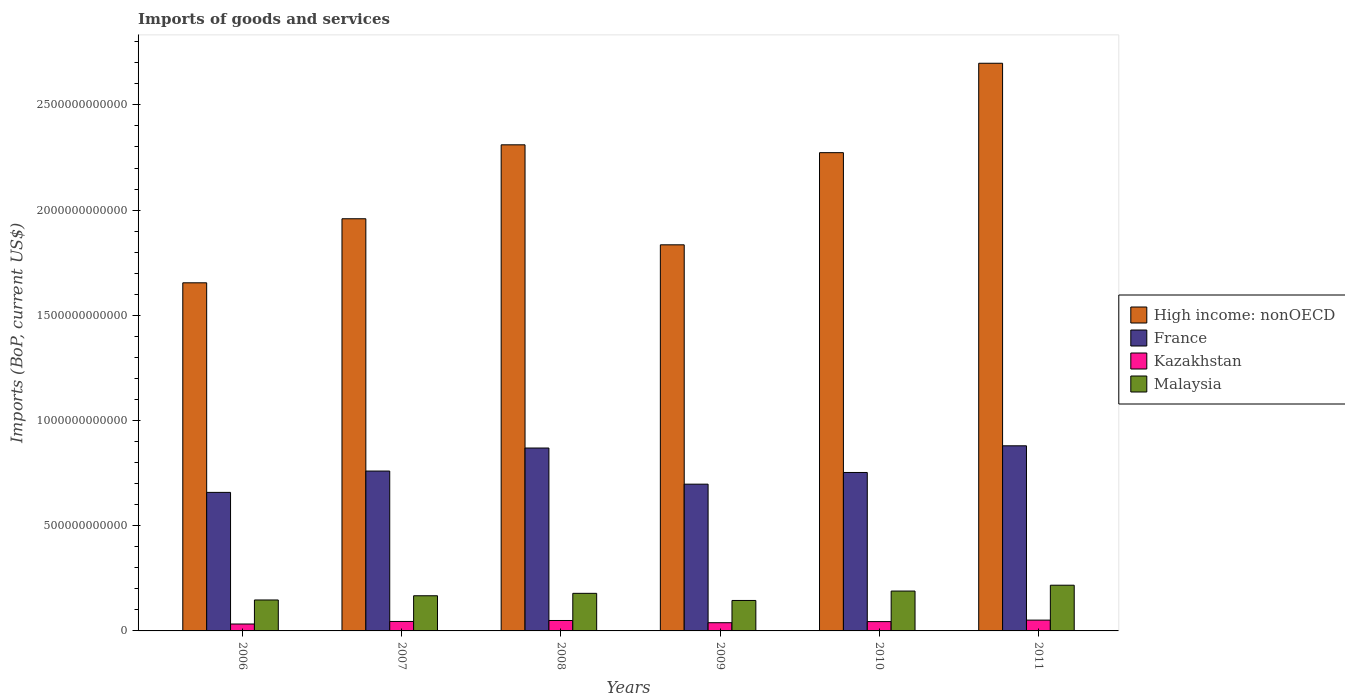Are the number of bars on each tick of the X-axis equal?
Offer a terse response. Yes. How many bars are there on the 4th tick from the left?
Your answer should be very brief. 4. What is the amount spent on imports in France in 2011?
Make the answer very short. 8.80e+11. Across all years, what is the maximum amount spent on imports in France?
Give a very brief answer. 8.80e+11. Across all years, what is the minimum amount spent on imports in Kazakhstan?
Make the answer very short. 3.29e+1. In which year was the amount spent on imports in Kazakhstan minimum?
Your response must be concise. 2006. What is the total amount spent on imports in High income: nonOECD in the graph?
Your answer should be very brief. 1.27e+13. What is the difference between the amount spent on imports in High income: nonOECD in 2007 and that in 2009?
Provide a short and direct response. 1.24e+11. What is the difference between the amount spent on imports in Kazakhstan in 2008 and the amount spent on imports in Malaysia in 2011?
Make the answer very short. -1.68e+11. What is the average amount spent on imports in France per year?
Offer a very short reply. 7.70e+11. In the year 2010, what is the difference between the amount spent on imports in High income: nonOECD and amount spent on imports in Kazakhstan?
Offer a terse response. 2.23e+12. What is the ratio of the amount spent on imports in High income: nonOECD in 2006 to that in 2007?
Your answer should be compact. 0.84. Is the difference between the amount spent on imports in High income: nonOECD in 2007 and 2010 greater than the difference between the amount spent on imports in Kazakhstan in 2007 and 2010?
Your response must be concise. No. What is the difference between the highest and the second highest amount spent on imports in Malaysia?
Provide a short and direct response. 2.78e+1. What is the difference between the highest and the lowest amount spent on imports in Kazakhstan?
Keep it short and to the point. 1.84e+1. In how many years, is the amount spent on imports in Kazakhstan greater than the average amount spent on imports in Kazakhstan taken over all years?
Provide a succinct answer. 4. What does the 1st bar from the left in 2009 represents?
Provide a succinct answer. High income: nonOECD. How many years are there in the graph?
Keep it short and to the point. 6. What is the difference between two consecutive major ticks on the Y-axis?
Provide a short and direct response. 5.00e+11. Are the values on the major ticks of Y-axis written in scientific E-notation?
Make the answer very short. No. Does the graph contain any zero values?
Offer a very short reply. No. Does the graph contain grids?
Give a very brief answer. No. Where does the legend appear in the graph?
Ensure brevity in your answer.  Center right. How are the legend labels stacked?
Your response must be concise. Vertical. What is the title of the graph?
Offer a very short reply. Imports of goods and services. What is the label or title of the Y-axis?
Your answer should be compact. Imports (BoP, current US$). What is the Imports (BoP, current US$) in High income: nonOECD in 2006?
Your answer should be compact. 1.65e+12. What is the Imports (BoP, current US$) of France in 2006?
Keep it short and to the point. 6.58e+11. What is the Imports (BoP, current US$) in Kazakhstan in 2006?
Provide a succinct answer. 3.29e+1. What is the Imports (BoP, current US$) in Malaysia in 2006?
Ensure brevity in your answer.  1.47e+11. What is the Imports (BoP, current US$) in High income: nonOECD in 2007?
Keep it short and to the point. 1.96e+12. What is the Imports (BoP, current US$) in France in 2007?
Offer a very short reply. 7.60e+11. What is the Imports (BoP, current US$) of Kazakhstan in 2007?
Give a very brief answer. 4.50e+1. What is the Imports (BoP, current US$) in Malaysia in 2007?
Your answer should be compact. 1.67e+11. What is the Imports (BoP, current US$) in High income: nonOECD in 2008?
Ensure brevity in your answer.  2.31e+12. What is the Imports (BoP, current US$) of France in 2008?
Keep it short and to the point. 8.69e+11. What is the Imports (BoP, current US$) in Kazakhstan in 2008?
Your answer should be compact. 4.96e+1. What is the Imports (BoP, current US$) in Malaysia in 2008?
Your answer should be very brief. 1.79e+11. What is the Imports (BoP, current US$) of High income: nonOECD in 2009?
Provide a short and direct response. 1.83e+12. What is the Imports (BoP, current US$) in France in 2009?
Give a very brief answer. 6.97e+11. What is the Imports (BoP, current US$) of Kazakhstan in 2009?
Provide a succinct answer. 3.90e+1. What is the Imports (BoP, current US$) of Malaysia in 2009?
Make the answer very short. 1.45e+11. What is the Imports (BoP, current US$) in High income: nonOECD in 2010?
Ensure brevity in your answer.  2.27e+12. What is the Imports (BoP, current US$) in France in 2010?
Offer a very short reply. 7.53e+11. What is the Imports (BoP, current US$) in Kazakhstan in 2010?
Give a very brief answer. 4.43e+1. What is the Imports (BoP, current US$) of Malaysia in 2010?
Provide a short and direct response. 1.89e+11. What is the Imports (BoP, current US$) in High income: nonOECD in 2011?
Offer a terse response. 2.70e+12. What is the Imports (BoP, current US$) in France in 2011?
Ensure brevity in your answer.  8.80e+11. What is the Imports (BoP, current US$) in Kazakhstan in 2011?
Offer a terse response. 5.13e+1. What is the Imports (BoP, current US$) in Malaysia in 2011?
Ensure brevity in your answer.  2.17e+11. Across all years, what is the maximum Imports (BoP, current US$) of High income: nonOECD?
Your answer should be very brief. 2.70e+12. Across all years, what is the maximum Imports (BoP, current US$) in France?
Provide a short and direct response. 8.80e+11. Across all years, what is the maximum Imports (BoP, current US$) of Kazakhstan?
Provide a short and direct response. 5.13e+1. Across all years, what is the maximum Imports (BoP, current US$) of Malaysia?
Ensure brevity in your answer.  2.17e+11. Across all years, what is the minimum Imports (BoP, current US$) in High income: nonOECD?
Your answer should be very brief. 1.65e+12. Across all years, what is the minimum Imports (BoP, current US$) in France?
Your answer should be compact. 6.58e+11. Across all years, what is the minimum Imports (BoP, current US$) of Kazakhstan?
Provide a short and direct response. 3.29e+1. Across all years, what is the minimum Imports (BoP, current US$) in Malaysia?
Make the answer very short. 1.45e+11. What is the total Imports (BoP, current US$) of High income: nonOECD in the graph?
Make the answer very short. 1.27e+13. What is the total Imports (BoP, current US$) in France in the graph?
Provide a short and direct response. 4.62e+12. What is the total Imports (BoP, current US$) in Kazakhstan in the graph?
Make the answer very short. 2.62e+11. What is the total Imports (BoP, current US$) of Malaysia in the graph?
Your response must be concise. 1.04e+12. What is the difference between the Imports (BoP, current US$) in High income: nonOECD in 2006 and that in 2007?
Offer a very short reply. -3.04e+11. What is the difference between the Imports (BoP, current US$) of France in 2006 and that in 2007?
Give a very brief answer. -1.01e+11. What is the difference between the Imports (BoP, current US$) of Kazakhstan in 2006 and that in 2007?
Your answer should be very brief. -1.21e+1. What is the difference between the Imports (BoP, current US$) in Malaysia in 2006 and that in 2007?
Make the answer very short. -2.00e+1. What is the difference between the Imports (BoP, current US$) in High income: nonOECD in 2006 and that in 2008?
Provide a succinct answer. -6.56e+11. What is the difference between the Imports (BoP, current US$) in France in 2006 and that in 2008?
Offer a very short reply. -2.11e+11. What is the difference between the Imports (BoP, current US$) in Kazakhstan in 2006 and that in 2008?
Your answer should be compact. -1.67e+1. What is the difference between the Imports (BoP, current US$) of Malaysia in 2006 and that in 2008?
Provide a short and direct response. -3.16e+1. What is the difference between the Imports (BoP, current US$) in High income: nonOECD in 2006 and that in 2009?
Offer a very short reply. -1.81e+11. What is the difference between the Imports (BoP, current US$) of France in 2006 and that in 2009?
Make the answer very short. -3.90e+1. What is the difference between the Imports (BoP, current US$) in Kazakhstan in 2006 and that in 2009?
Offer a very short reply. -6.12e+09. What is the difference between the Imports (BoP, current US$) of Malaysia in 2006 and that in 2009?
Provide a succinct answer. 2.30e+09. What is the difference between the Imports (BoP, current US$) of High income: nonOECD in 2006 and that in 2010?
Your answer should be compact. -6.19e+11. What is the difference between the Imports (BoP, current US$) of France in 2006 and that in 2010?
Your response must be concise. -9.46e+1. What is the difference between the Imports (BoP, current US$) of Kazakhstan in 2006 and that in 2010?
Offer a very short reply. -1.14e+1. What is the difference between the Imports (BoP, current US$) of Malaysia in 2006 and that in 2010?
Ensure brevity in your answer.  -4.24e+1. What is the difference between the Imports (BoP, current US$) of High income: nonOECD in 2006 and that in 2011?
Make the answer very short. -1.04e+12. What is the difference between the Imports (BoP, current US$) in France in 2006 and that in 2011?
Your answer should be compact. -2.21e+11. What is the difference between the Imports (BoP, current US$) in Kazakhstan in 2006 and that in 2011?
Ensure brevity in your answer.  -1.84e+1. What is the difference between the Imports (BoP, current US$) in Malaysia in 2006 and that in 2011?
Provide a succinct answer. -7.02e+1. What is the difference between the Imports (BoP, current US$) in High income: nonOECD in 2007 and that in 2008?
Provide a succinct answer. -3.51e+11. What is the difference between the Imports (BoP, current US$) of France in 2007 and that in 2008?
Ensure brevity in your answer.  -1.09e+11. What is the difference between the Imports (BoP, current US$) of Kazakhstan in 2007 and that in 2008?
Provide a short and direct response. -4.58e+09. What is the difference between the Imports (BoP, current US$) in Malaysia in 2007 and that in 2008?
Offer a terse response. -1.16e+1. What is the difference between the Imports (BoP, current US$) in High income: nonOECD in 2007 and that in 2009?
Ensure brevity in your answer.  1.24e+11. What is the difference between the Imports (BoP, current US$) in France in 2007 and that in 2009?
Offer a very short reply. 6.23e+1. What is the difference between the Imports (BoP, current US$) in Kazakhstan in 2007 and that in 2009?
Provide a short and direct response. 5.99e+09. What is the difference between the Imports (BoP, current US$) of Malaysia in 2007 and that in 2009?
Keep it short and to the point. 2.23e+1. What is the difference between the Imports (BoP, current US$) of High income: nonOECD in 2007 and that in 2010?
Your answer should be compact. -3.14e+11. What is the difference between the Imports (BoP, current US$) of France in 2007 and that in 2010?
Offer a terse response. 6.70e+09. What is the difference between the Imports (BoP, current US$) in Kazakhstan in 2007 and that in 2010?
Make the answer very short. 7.30e+08. What is the difference between the Imports (BoP, current US$) of Malaysia in 2007 and that in 2010?
Your answer should be very brief. -2.24e+1. What is the difference between the Imports (BoP, current US$) of High income: nonOECD in 2007 and that in 2011?
Offer a terse response. -7.39e+11. What is the difference between the Imports (BoP, current US$) in France in 2007 and that in 2011?
Your response must be concise. -1.20e+11. What is the difference between the Imports (BoP, current US$) in Kazakhstan in 2007 and that in 2011?
Provide a short and direct response. -6.33e+09. What is the difference between the Imports (BoP, current US$) of Malaysia in 2007 and that in 2011?
Your answer should be compact. -5.02e+1. What is the difference between the Imports (BoP, current US$) of High income: nonOECD in 2008 and that in 2009?
Ensure brevity in your answer.  4.75e+11. What is the difference between the Imports (BoP, current US$) of France in 2008 and that in 2009?
Provide a succinct answer. 1.72e+11. What is the difference between the Imports (BoP, current US$) in Kazakhstan in 2008 and that in 2009?
Give a very brief answer. 1.06e+1. What is the difference between the Imports (BoP, current US$) in Malaysia in 2008 and that in 2009?
Your response must be concise. 3.39e+1. What is the difference between the Imports (BoP, current US$) in High income: nonOECD in 2008 and that in 2010?
Your answer should be very brief. 3.72e+1. What is the difference between the Imports (BoP, current US$) of France in 2008 and that in 2010?
Ensure brevity in your answer.  1.16e+11. What is the difference between the Imports (BoP, current US$) of Kazakhstan in 2008 and that in 2010?
Your answer should be compact. 5.31e+09. What is the difference between the Imports (BoP, current US$) of Malaysia in 2008 and that in 2010?
Your answer should be compact. -1.08e+1. What is the difference between the Imports (BoP, current US$) in High income: nonOECD in 2008 and that in 2011?
Ensure brevity in your answer.  -3.88e+11. What is the difference between the Imports (BoP, current US$) in France in 2008 and that in 2011?
Give a very brief answer. -1.06e+1. What is the difference between the Imports (BoP, current US$) in Kazakhstan in 2008 and that in 2011?
Make the answer very short. -1.75e+09. What is the difference between the Imports (BoP, current US$) of Malaysia in 2008 and that in 2011?
Your answer should be compact. -3.86e+1. What is the difference between the Imports (BoP, current US$) in High income: nonOECD in 2009 and that in 2010?
Your answer should be very brief. -4.38e+11. What is the difference between the Imports (BoP, current US$) of France in 2009 and that in 2010?
Your response must be concise. -5.56e+1. What is the difference between the Imports (BoP, current US$) in Kazakhstan in 2009 and that in 2010?
Your answer should be compact. -5.26e+09. What is the difference between the Imports (BoP, current US$) of Malaysia in 2009 and that in 2010?
Your answer should be very brief. -4.47e+1. What is the difference between the Imports (BoP, current US$) of High income: nonOECD in 2009 and that in 2011?
Provide a succinct answer. -8.63e+11. What is the difference between the Imports (BoP, current US$) of France in 2009 and that in 2011?
Provide a short and direct response. -1.82e+11. What is the difference between the Imports (BoP, current US$) of Kazakhstan in 2009 and that in 2011?
Offer a very short reply. -1.23e+1. What is the difference between the Imports (BoP, current US$) of Malaysia in 2009 and that in 2011?
Provide a succinct answer. -7.25e+1. What is the difference between the Imports (BoP, current US$) of High income: nonOECD in 2010 and that in 2011?
Provide a succinct answer. -4.25e+11. What is the difference between the Imports (BoP, current US$) of France in 2010 and that in 2011?
Your answer should be compact. -1.27e+11. What is the difference between the Imports (BoP, current US$) of Kazakhstan in 2010 and that in 2011?
Offer a very short reply. -7.06e+09. What is the difference between the Imports (BoP, current US$) of Malaysia in 2010 and that in 2011?
Your response must be concise. -2.78e+1. What is the difference between the Imports (BoP, current US$) in High income: nonOECD in 2006 and the Imports (BoP, current US$) in France in 2007?
Your response must be concise. 8.95e+11. What is the difference between the Imports (BoP, current US$) of High income: nonOECD in 2006 and the Imports (BoP, current US$) of Kazakhstan in 2007?
Ensure brevity in your answer.  1.61e+12. What is the difference between the Imports (BoP, current US$) of High income: nonOECD in 2006 and the Imports (BoP, current US$) of Malaysia in 2007?
Provide a succinct answer. 1.49e+12. What is the difference between the Imports (BoP, current US$) in France in 2006 and the Imports (BoP, current US$) in Kazakhstan in 2007?
Keep it short and to the point. 6.13e+11. What is the difference between the Imports (BoP, current US$) of France in 2006 and the Imports (BoP, current US$) of Malaysia in 2007?
Provide a succinct answer. 4.91e+11. What is the difference between the Imports (BoP, current US$) in Kazakhstan in 2006 and the Imports (BoP, current US$) in Malaysia in 2007?
Give a very brief answer. -1.34e+11. What is the difference between the Imports (BoP, current US$) in High income: nonOECD in 2006 and the Imports (BoP, current US$) in France in 2008?
Make the answer very short. 7.85e+11. What is the difference between the Imports (BoP, current US$) of High income: nonOECD in 2006 and the Imports (BoP, current US$) of Kazakhstan in 2008?
Provide a short and direct response. 1.60e+12. What is the difference between the Imports (BoP, current US$) in High income: nonOECD in 2006 and the Imports (BoP, current US$) in Malaysia in 2008?
Offer a terse response. 1.48e+12. What is the difference between the Imports (BoP, current US$) in France in 2006 and the Imports (BoP, current US$) in Kazakhstan in 2008?
Your answer should be compact. 6.09e+11. What is the difference between the Imports (BoP, current US$) in France in 2006 and the Imports (BoP, current US$) in Malaysia in 2008?
Make the answer very short. 4.80e+11. What is the difference between the Imports (BoP, current US$) of Kazakhstan in 2006 and the Imports (BoP, current US$) of Malaysia in 2008?
Make the answer very short. -1.46e+11. What is the difference between the Imports (BoP, current US$) in High income: nonOECD in 2006 and the Imports (BoP, current US$) in France in 2009?
Your response must be concise. 9.57e+11. What is the difference between the Imports (BoP, current US$) in High income: nonOECD in 2006 and the Imports (BoP, current US$) in Kazakhstan in 2009?
Offer a terse response. 1.62e+12. What is the difference between the Imports (BoP, current US$) in High income: nonOECD in 2006 and the Imports (BoP, current US$) in Malaysia in 2009?
Give a very brief answer. 1.51e+12. What is the difference between the Imports (BoP, current US$) of France in 2006 and the Imports (BoP, current US$) of Kazakhstan in 2009?
Offer a very short reply. 6.19e+11. What is the difference between the Imports (BoP, current US$) of France in 2006 and the Imports (BoP, current US$) of Malaysia in 2009?
Provide a short and direct response. 5.14e+11. What is the difference between the Imports (BoP, current US$) in Kazakhstan in 2006 and the Imports (BoP, current US$) in Malaysia in 2009?
Keep it short and to the point. -1.12e+11. What is the difference between the Imports (BoP, current US$) in High income: nonOECD in 2006 and the Imports (BoP, current US$) in France in 2010?
Provide a succinct answer. 9.01e+11. What is the difference between the Imports (BoP, current US$) of High income: nonOECD in 2006 and the Imports (BoP, current US$) of Kazakhstan in 2010?
Your answer should be compact. 1.61e+12. What is the difference between the Imports (BoP, current US$) of High income: nonOECD in 2006 and the Imports (BoP, current US$) of Malaysia in 2010?
Keep it short and to the point. 1.46e+12. What is the difference between the Imports (BoP, current US$) in France in 2006 and the Imports (BoP, current US$) in Kazakhstan in 2010?
Your answer should be very brief. 6.14e+11. What is the difference between the Imports (BoP, current US$) in France in 2006 and the Imports (BoP, current US$) in Malaysia in 2010?
Offer a terse response. 4.69e+11. What is the difference between the Imports (BoP, current US$) of Kazakhstan in 2006 and the Imports (BoP, current US$) of Malaysia in 2010?
Keep it short and to the point. -1.57e+11. What is the difference between the Imports (BoP, current US$) in High income: nonOECD in 2006 and the Imports (BoP, current US$) in France in 2011?
Ensure brevity in your answer.  7.75e+11. What is the difference between the Imports (BoP, current US$) in High income: nonOECD in 2006 and the Imports (BoP, current US$) in Kazakhstan in 2011?
Ensure brevity in your answer.  1.60e+12. What is the difference between the Imports (BoP, current US$) of High income: nonOECD in 2006 and the Imports (BoP, current US$) of Malaysia in 2011?
Keep it short and to the point. 1.44e+12. What is the difference between the Imports (BoP, current US$) of France in 2006 and the Imports (BoP, current US$) of Kazakhstan in 2011?
Offer a very short reply. 6.07e+11. What is the difference between the Imports (BoP, current US$) of France in 2006 and the Imports (BoP, current US$) of Malaysia in 2011?
Give a very brief answer. 4.41e+11. What is the difference between the Imports (BoP, current US$) in Kazakhstan in 2006 and the Imports (BoP, current US$) in Malaysia in 2011?
Make the answer very short. -1.84e+11. What is the difference between the Imports (BoP, current US$) in High income: nonOECD in 2007 and the Imports (BoP, current US$) in France in 2008?
Give a very brief answer. 1.09e+12. What is the difference between the Imports (BoP, current US$) of High income: nonOECD in 2007 and the Imports (BoP, current US$) of Kazakhstan in 2008?
Provide a succinct answer. 1.91e+12. What is the difference between the Imports (BoP, current US$) of High income: nonOECD in 2007 and the Imports (BoP, current US$) of Malaysia in 2008?
Keep it short and to the point. 1.78e+12. What is the difference between the Imports (BoP, current US$) in France in 2007 and the Imports (BoP, current US$) in Kazakhstan in 2008?
Ensure brevity in your answer.  7.10e+11. What is the difference between the Imports (BoP, current US$) of France in 2007 and the Imports (BoP, current US$) of Malaysia in 2008?
Provide a short and direct response. 5.81e+11. What is the difference between the Imports (BoP, current US$) of Kazakhstan in 2007 and the Imports (BoP, current US$) of Malaysia in 2008?
Provide a short and direct response. -1.34e+11. What is the difference between the Imports (BoP, current US$) in High income: nonOECD in 2007 and the Imports (BoP, current US$) in France in 2009?
Provide a short and direct response. 1.26e+12. What is the difference between the Imports (BoP, current US$) in High income: nonOECD in 2007 and the Imports (BoP, current US$) in Kazakhstan in 2009?
Provide a succinct answer. 1.92e+12. What is the difference between the Imports (BoP, current US$) of High income: nonOECD in 2007 and the Imports (BoP, current US$) of Malaysia in 2009?
Offer a very short reply. 1.81e+12. What is the difference between the Imports (BoP, current US$) in France in 2007 and the Imports (BoP, current US$) in Kazakhstan in 2009?
Make the answer very short. 7.21e+11. What is the difference between the Imports (BoP, current US$) in France in 2007 and the Imports (BoP, current US$) in Malaysia in 2009?
Offer a terse response. 6.15e+11. What is the difference between the Imports (BoP, current US$) of Kazakhstan in 2007 and the Imports (BoP, current US$) of Malaysia in 2009?
Give a very brief answer. -9.98e+1. What is the difference between the Imports (BoP, current US$) in High income: nonOECD in 2007 and the Imports (BoP, current US$) in France in 2010?
Your response must be concise. 1.21e+12. What is the difference between the Imports (BoP, current US$) in High income: nonOECD in 2007 and the Imports (BoP, current US$) in Kazakhstan in 2010?
Your response must be concise. 1.91e+12. What is the difference between the Imports (BoP, current US$) in High income: nonOECD in 2007 and the Imports (BoP, current US$) in Malaysia in 2010?
Your answer should be very brief. 1.77e+12. What is the difference between the Imports (BoP, current US$) of France in 2007 and the Imports (BoP, current US$) of Kazakhstan in 2010?
Offer a very short reply. 7.15e+11. What is the difference between the Imports (BoP, current US$) in France in 2007 and the Imports (BoP, current US$) in Malaysia in 2010?
Offer a very short reply. 5.70e+11. What is the difference between the Imports (BoP, current US$) of Kazakhstan in 2007 and the Imports (BoP, current US$) of Malaysia in 2010?
Provide a short and direct response. -1.44e+11. What is the difference between the Imports (BoP, current US$) of High income: nonOECD in 2007 and the Imports (BoP, current US$) of France in 2011?
Offer a very short reply. 1.08e+12. What is the difference between the Imports (BoP, current US$) of High income: nonOECD in 2007 and the Imports (BoP, current US$) of Kazakhstan in 2011?
Your response must be concise. 1.91e+12. What is the difference between the Imports (BoP, current US$) in High income: nonOECD in 2007 and the Imports (BoP, current US$) in Malaysia in 2011?
Give a very brief answer. 1.74e+12. What is the difference between the Imports (BoP, current US$) in France in 2007 and the Imports (BoP, current US$) in Kazakhstan in 2011?
Offer a terse response. 7.08e+11. What is the difference between the Imports (BoP, current US$) of France in 2007 and the Imports (BoP, current US$) of Malaysia in 2011?
Ensure brevity in your answer.  5.42e+11. What is the difference between the Imports (BoP, current US$) of Kazakhstan in 2007 and the Imports (BoP, current US$) of Malaysia in 2011?
Your response must be concise. -1.72e+11. What is the difference between the Imports (BoP, current US$) in High income: nonOECD in 2008 and the Imports (BoP, current US$) in France in 2009?
Offer a very short reply. 1.61e+12. What is the difference between the Imports (BoP, current US$) of High income: nonOECD in 2008 and the Imports (BoP, current US$) of Kazakhstan in 2009?
Your answer should be compact. 2.27e+12. What is the difference between the Imports (BoP, current US$) of High income: nonOECD in 2008 and the Imports (BoP, current US$) of Malaysia in 2009?
Your answer should be compact. 2.17e+12. What is the difference between the Imports (BoP, current US$) in France in 2008 and the Imports (BoP, current US$) in Kazakhstan in 2009?
Your answer should be very brief. 8.30e+11. What is the difference between the Imports (BoP, current US$) of France in 2008 and the Imports (BoP, current US$) of Malaysia in 2009?
Give a very brief answer. 7.24e+11. What is the difference between the Imports (BoP, current US$) of Kazakhstan in 2008 and the Imports (BoP, current US$) of Malaysia in 2009?
Make the answer very short. -9.52e+1. What is the difference between the Imports (BoP, current US$) of High income: nonOECD in 2008 and the Imports (BoP, current US$) of France in 2010?
Offer a terse response. 1.56e+12. What is the difference between the Imports (BoP, current US$) in High income: nonOECD in 2008 and the Imports (BoP, current US$) in Kazakhstan in 2010?
Keep it short and to the point. 2.27e+12. What is the difference between the Imports (BoP, current US$) in High income: nonOECD in 2008 and the Imports (BoP, current US$) in Malaysia in 2010?
Provide a succinct answer. 2.12e+12. What is the difference between the Imports (BoP, current US$) of France in 2008 and the Imports (BoP, current US$) of Kazakhstan in 2010?
Provide a succinct answer. 8.25e+11. What is the difference between the Imports (BoP, current US$) in France in 2008 and the Imports (BoP, current US$) in Malaysia in 2010?
Your answer should be very brief. 6.80e+11. What is the difference between the Imports (BoP, current US$) in Kazakhstan in 2008 and the Imports (BoP, current US$) in Malaysia in 2010?
Your answer should be very brief. -1.40e+11. What is the difference between the Imports (BoP, current US$) of High income: nonOECD in 2008 and the Imports (BoP, current US$) of France in 2011?
Offer a very short reply. 1.43e+12. What is the difference between the Imports (BoP, current US$) of High income: nonOECD in 2008 and the Imports (BoP, current US$) of Kazakhstan in 2011?
Give a very brief answer. 2.26e+12. What is the difference between the Imports (BoP, current US$) in High income: nonOECD in 2008 and the Imports (BoP, current US$) in Malaysia in 2011?
Make the answer very short. 2.09e+12. What is the difference between the Imports (BoP, current US$) in France in 2008 and the Imports (BoP, current US$) in Kazakhstan in 2011?
Your answer should be compact. 8.18e+11. What is the difference between the Imports (BoP, current US$) of France in 2008 and the Imports (BoP, current US$) of Malaysia in 2011?
Your response must be concise. 6.52e+11. What is the difference between the Imports (BoP, current US$) in Kazakhstan in 2008 and the Imports (BoP, current US$) in Malaysia in 2011?
Your response must be concise. -1.68e+11. What is the difference between the Imports (BoP, current US$) in High income: nonOECD in 2009 and the Imports (BoP, current US$) in France in 2010?
Make the answer very short. 1.08e+12. What is the difference between the Imports (BoP, current US$) of High income: nonOECD in 2009 and the Imports (BoP, current US$) of Kazakhstan in 2010?
Keep it short and to the point. 1.79e+12. What is the difference between the Imports (BoP, current US$) of High income: nonOECD in 2009 and the Imports (BoP, current US$) of Malaysia in 2010?
Ensure brevity in your answer.  1.65e+12. What is the difference between the Imports (BoP, current US$) of France in 2009 and the Imports (BoP, current US$) of Kazakhstan in 2010?
Provide a succinct answer. 6.53e+11. What is the difference between the Imports (BoP, current US$) of France in 2009 and the Imports (BoP, current US$) of Malaysia in 2010?
Offer a very short reply. 5.08e+11. What is the difference between the Imports (BoP, current US$) in Kazakhstan in 2009 and the Imports (BoP, current US$) in Malaysia in 2010?
Your response must be concise. -1.50e+11. What is the difference between the Imports (BoP, current US$) of High income: nonOECD in 2009 and the Imports (BoP, current US$) of France in 2011?
Provide a short and direct response. 9.55e+11. What is the difference between the Imports (BoP, current US$) in High income: nonOECD in 2009 and the Imports (BoP, current US$) in Kazakhstan in 2011?
Provide a succinct answer. 1.78e+12. What is the difference between the Imports (BoP, current US$) of High income: nonOECD in 2009 and the Imports (BoP, current US$) of Malaysia in 2011?
Provide a succinct answer. 1.62e+12. What is the difference between the Imports (BoP, current US$) of France in 2009 and the Imports (BoP, current US$) of Kazakhstan in 2011?
Provide a succinct answer. 6.46e+11. What is the difference between the Imports (BoP, current US$) of France in 2009 and the Imports (BoP, current US$) of Malaysia in 2011?
Your answer should be compact. 4.80e+11. What is the difference between the Imports (BoP, current US$) in Kazakhstan in 2009 and the Imports (BoP, current US$) in Malaysia in 2011?
Your response must be concise. -1.78e+11. What is the difference between the Imports (BoP, current US$) in High income: nonOECD in 2010 and the Imports (BoP, current US$) in France in 2011?
Your answer should be very brief. 1.39e+12. What is the difference between the Imports (BoP, current US$) in High income: nonOECD in 2010 and the Imports (BoP, current US$) in Kazakhstan in 2011?
Offer a very short reply. 2.22e+12. What is the difference between the Imports (BoP, current US$) of High income: nonOECD in 2010 and the Imports (BoP, current US$) of Malaysia in 2011?
Your answer should be very brief. 2.06e+12. What is the difference between the Imports (BoP, current US$) in France in 2010 and the Imports (BoP, current US$) in Kazakhstan in 2011?
Your response must be concise. 7.02e+11. What is the difference between the Imports (BoP, current US$) of France in 2010 and the Imports (BoP, current US$) of Malaysia in 2011?
Your answer should be compact. 5.36e+11. What is the difference between the Imports (BoP, current US$) in Kazakhstan in 2010 and the Imports (BoP, current US$) in Malaysia in 2011?
Make the answer very short. -1.73e+11. What is the average Imports (BoP, current US$) of High income: nonOECD per year?
Give a very brief answer. 2.12e+12. What is the average Imports (BoP, current US$) in France per year?
Keep it short and to the point. 7.70e+11. What is the average Imports (BoP, current US$) of Kazakhstan per year?
Make the answer very short. 4.37e+1. What is the average Imports (BoP, current US$) in Malaysia per year?
Ensure brevity in your answer.  1.74e+11. In the year 2006, what is the difference between the Imports (BoP, current US$) of High income: nonOECD and Imports (BoP, current US$) of France?
Your response must be concise. 9.96e+11. In the year 2006, what is the difference between the Imports (BoP, current US$) of High income: nonOECD and Imports (BoP, current US$) of Kazakhstan?
Offer a very short reply. 1.62e+12. In the year 2006, what is the difference between the Imports (BoP, current US$) of High income: nonOECD and Imports (BoP, current US$) of Malaysia?
Provide a succinct answer. 1.51e+12. In the year 2006, what is the difference between the Imports (BoP, current US$) of France and Imports (BoP, current US$) of Kazakhstan?
Your response must be concise. 6.26e+11. In the year 2006, what is the difference between the Imports (BoP, current US$) of France and Imports (BoP, current US$) of Malaysia?
Provide a succinct answer. 5.11e+11. In the year 2006, what is the difference between the Imports (BoP, current US$) in Kazakhstan and Imports (BoP, current US$) in Malaysia?
Your response must be concise. -1.14e+11. In the year 2007, what is the difference between the Imports (BoP, current US$) of High income: nonOECD and Imports (BoP, current US$) of France?
Provide a succinct answer. 1.20e+12. In the year 2007, what is the difference between the Imports (BoP, current US$) of High income: nonOECD and Imports (BoP, current US$) of Kazakhstan?
Give a very brief answer. 1.91e+12. In the year 2007, what is the difference between the Imports (BoP, current US$) of High income: nonOECD and Imports (BoP, current US$) of Malaysia?
Ensure brevity in your answer.  1.79e+12. In the year 2007, what is the difference between the Imports (BoP, current US$) of France and Imports (BoP, current US$) of Kazakhstan?
Provide a succinct answer. 7.15e+11. In the year 2007, what is the difference between the Imports (BoP, current US$) of France and Imports (BoP, current US$) of Malaysia?
Your response must be concise. 5.93e+11. In the year 2007, what is the difference between the Imports (BoP, current US$) of Kazakhstan and Imports (BoP, current US$) of Malaysia?
Your answer should be very brief. -1.22e+11. In the year 2008, what is the difference between the Imports (BoP, current US$) of High income: nonOECD and Imports (BoP, current US$) of France?
Offer a very short reply. 1.44e+12. In the year 2008, what is the difference between the Imports (BoP, current US$) in High income: nonOECD and Imports (BoP, current US$) in Kazakhstan?
Provide a short and direct response. 2.26e+12. In the year 2008, what is the difference between the Imports (BoP, current US$) in High income: nonOECD and Imports (BoP, current US$) in Malaysia?
Give a very brief answer. 2.13e+12. In the year 2008, what is the difference between the Imports (BoP, current US$) of France and Imports (BoP, current US$) of Kazakhstan?
Your answer should be compact. 8.20e+11. In the year 2008, what is the difference between the Imports (BoP, current US$) of France and Imports (BoP, current US$) of Malaysia?
Give a very brief answer. 6.91e+11. In the year 2008, what is the difference between the Imports (BoP, current US$) of Kazakhstan and Imports (BoP, current US$) of Malaysia?
Your response must be concise. -1.29e+11. In the year 2009, what is the difference between the Imports (BoP, current US$) in High income: nonOECD and Imports (BoP, current US$) in France?
Offer a very short reply. 1.14e+12. In the year 2009, what is the difference between the Imports (BoP, current US$) of High income: nonOECD and Imports (BoP, current US$) of Kazakhstan?
Make the answer very short. 1.80e+12. In the year 2009, what is the difference between the Imports (BoP, current US$) of High income: nonOECD and Imports (BoP, current US$) of Malaysia?
Keep it short and to the point. 1.69e+12. In the year 2009, what is the difference between the Imports (BoP, current US$) of France and Imports (BoP, current US$) of Kazakhstan?
Your response must be concise. 6.58e+11. In the year 2009, what is the difference between the Imports (BoP, current US$) of France and Imports (BoP, current US$) of Malaysia?
Make the answer very short. 5.53e+11. In the year 2009, what is the difference between the Imports (BoP, current US$) of Kazakhstan and Imports (BoP, current US$) of Malaysia?
Provide a short and direct response. -1.06e+11. In the year 2010, what is the difference between the Imports (BoP, current US$) of High income: nonOECD and Imports (BoP, current US$) of France?
Your answer should be compact. 1.52e+12. In the year 2010, what is the difference between the Imports (BoP, current US$) of High income: nonOECD and Imports (BoP, current US$) of Kazakhstan?
Your response must be concise. 2.23e+12. In the year 2010, what is the difference between the Imports (BoP, current US$) in High income: nonOECD and Imports (BoP, current US$) in Malaysia?
Make the answer very short. 2.08e+12. In the year 2010, what is the difference between the Imports (BoP, current US$) in France and Imports (BoP, current US$) in Kazakhstan?
Make the answer very short. 7.09e+11. In the year 2010, what is the difference between the Imports (BoP, current US$) of France and Imports (BoP, current US$) of Malaysia?
Make the answer very short. 5.64e+11. In the year 2010, what is the difference between the Imports (BoP, current US$) in Kazakhstan and Imports (BoP, current US$) in Malaysia?
Offer a very short reply. -1.45e+11. In the year 2011, what is the difference between the Imports (BoP, current US$) of High income: nonOECD and Imports (BoP, current US$) of France?
Your answer should be very brief. 1.82e+12. In the year 2011, what is the difference between the Imports (BoP, current US$) in High income: nonOECD and Imports (BoP, current US$) in Kazakhstan?
Your answer should be very brief. 2.65e+12. In the year 2011, what is the difference between the Imports (BoP, current US$) of High income: nonOECD and Imports (BoP, current US$) of Malaysia?
Offer a very short reply. 2.48e+12. In the year 2011, what is the difference between the Imports (BoP, current US$) of France and Imports (BoP, current US$) of Kazakhstan?
Offer a very short reply. 8.28e+11. In the year 2011, what is the difference between the Imports (BoP, current US$) in France and Imports (BoP, current US$) in Malaysia?
Give a very brief answer. 6.63e+11. In the year 2011, what is the difference between the Imports (BoP, current US$) of Kazakhstan and Imports (BoP, current US$) of Malaysia?
Offer a very short reply. -1.66e+11. What is the ratio of the Imports (BoP, current US$) of High income: nonOECD in 2006 to that in 2007?
Keep it short and to the point. 0.84. What is the ratio of the Imports (BoP, current US$) in France in 2006 to that in 2007?
Your response must be concise. 0.87. What is the ratio of the Imports (BoP, current US$) of Kazakhstan in 2006 to that in 2007?
Your answer should be very brief. 0.73. What is the ratio of the Imports (BoP, current US$) of Malaysia in 2006 to that in 2007?
Your answer should be compact. 0.88. What is the ratio of the Imports (BoP, current US$) of High income: nonOECD in 2006 to that in 2008?
Your answer should be very brief. 0.72. What is the ratio of the Imports (BoP, current US$) in France in 2006 to that in 2008?
Ensure brevity in your answer.  0.76. What is the ratio of the Imports (BoP, current US$) in Kazakhstan in 2006 to that in 2008?
Ensure brevity in your answer.  0.66. What is the ratio of the Imports (BoP, current US$) of Malaysia in 2006 to that in 2008?
Give a very brief answer. 0.82. What is the ratio of the Imports (BoP, current US$) of High income: nonOECD in 2006 to that in 2009?
Offer a very short reply. 0.9. What is the ratio of the Imports (BoP, current US$) in France in 2006 to that in 2009?
Give a very brief answer. 0.94. What is the ratio of the Imports (BoP, current US$) in Kazakhstan in 2006 to that in 2009?
Ensure brevity in your answer.  0.84. What is the ratio of the Imports (BoP, current US$) of Malaysia in 2006 to that in 2009?
Your response must be concise. 1.02. What is the ratio of the Imports (BoP, current US$) of High income: nonOECD in 2006 to that in 2010?
Keep it short and to the point. 0.73. What is the ratio of the Imports (BoP, current US$) in France in 2006 to that in 2010?
Your answer should be compact. 0.87. What is the ratio of the Imports (BoP, current US$) in Kazakhstan in 2006 to that in 2010?
Your answer should be very brief. 0.74. What is the ratio of the Imports (BoP, current US$) of Malaysia in 2006 to that in 2010?
Provide a succinct answer. 0.78. What is the ratio of the Imports (BoP, current US$) of High income: nonOECD in 2006 to that in 2011?
Give a very brief answer. 0.61. What is the ratio of the Imports (BoP, current US$) of France in 2006 to that in 2011?
Offer a terse response. 0.75. What is the ratio of the Imports (BoP, current US$) of Kazakhstan in 2006 to that in 2011?
Provide a short and direct response. 0.64. What is the ratio of the Imports (BoP, current US$) in Malaysia in 2006 to that in 2011?
Keep it short and to the point. 0.68. What is the ratio of the Imports (BoP, current US$) in High income: nonOECD in 2007 to that in 2008?
Provide a succinct answer. 0.85. What is the ratio of the Imports (BoP, current US$) of France in 2007 to that in 2008?
Make the answer very short. 0.87. What is the ratio of the Imports (BoP, current US$) in Kazakhstan in 2007 to that in 2008?
Keep it short and to the point. 0.91. What is the ratio of the Imports (BoP, current US$) in Malaysia in 2007 to that in 2008?
Make the answer very short. 0.94. What is the ratio of the Imports (BoP, current US$) of High income: nonOECD in 2007 to that in 2009?
Give a very brief answer. 1.07. What is the ratio of the Imports (BoP, current US$) in France in 2007 to that in 2009?
Make the answer very short. 1.09. What is the ratio of the Imports (BoP, current US$) in Kazakhstan in 2007 to that in 2009?
Ensure brevity in your answer.  1.15. What is the ratio of the Imports (BoP, current US$) in Malaysia in 2007 to that in 2009?
Your response must be concise. 1.15. What is the ratio of the Imports (BoP, current US$) in High income: nonOECD in 2007 to that in 2010?
Provide a succinct answer. 0.86. What is the ratio of the Imports (BoP, current US$) of France in 2007 to that in 2010?
Your answer should be very brief. 1.01. What is the ratio of the Imports (BoP, current US$) of Kazakhstan in 2007 to that in 2010?
Make the answer very short. 1.02. What is the ratio of the Imports (BoP, current US$) in Malaysia in 2007 to that in 2010?
Your response must be concise. 0.88. What is the ratio of the Imports (BoP, current US$) in High income: nonOECD in 2007 to that in 2011?
Make the answer very short. 0.73. What is the ratio of the Imports (BoP, current US$) of France in 2007 to that in 2011?
Make the answer very short. 0.86. What is the ratio of the Imports (BoP, current US$) in Kazakhstan in 2007 to that in 2011?
Offer a terse response. 0.88. What is the ratio of the Imports (BoP, current US$) of Malaysia in 2007 to that in 2011?
Your answer should be compact. 0.77. What is the ratio of the Imports (BoP, current US$) of High income: nonOECD in 2008 to that in 2009?
Keep it short and to the point. 1.26. What is the ratio of the Imports (BoP, current US$) of France in 2008 to that in 2009?
Provide a succinct answer. 1.25. What is the ratio of the Imports (BoP, current US$) in Kazakhstan in 2008 to that in 2009?
Your response must be concise. 1.27. What is the ratio of the Imports (BoP, current US$) of Malaysia in 2008 to that in 2009?
Your answer should be compact. 1.23. What is the ratio of the Imports (BoP, current US$) in High income: nonOECD in 2008 to that in 2010?
Give a very brief answer. 1.02. What is the ratio of the Imports (BoP, current US$) in France in 2008 to that in 2010?
Make the answer very short. 1.15. What is the ratio of the Imports (BoP, current US$) of Kazakhstan in 2008 to that in 2010?
Your response must be concise. 1.12. What is the ratio of the Imports (BoP, current US$) of Malaysia in 2008 to that in 2010?
Provide a succinct answer. 0.94. What is the ratio of the Imports (BoP, current US$) in High income: nonOECD in 2008 to that in 2011?
Make the answer very short. 0.86. What is the ratio of the Imports (BoP, current US$) in Kazakhstan in 2008 to that in 2011?
Offer a terse response. 0.97. What is the ratio of the Imports (BoP, current US$) in Malaysia in 2008 to that in 2011?
Give a very brief answer. 0.82. What is the ratio of the Imports (BoP, current US$) in High income: nonOECD in 2009 to that in 2010?
Make the answer very short. 0.81. What is the ratio of the Imports (BoP, current US$) of France in 2009 to that in 2010?
Your answer should be compact. 0.93. What is the ratio of the Imports (BoP, current US$) in Kazakhstan in 2009 to that in 2010?
Ensure brevity in your answer.  0.88. What is the ratio of the Imports (BoP, current US$) in Malaysia in 2009 to that in 2010?
Your answer should be very brief. 0.76. What is the ratio of the Imports (BoP, current US$) of High income: nonOECD in 2009 to that in 2011?
Your response must be concise. 0.68. What is the ratio of the Imports (BoP, current US$) of France in 2009 to that in 2011?
Offer a very short reply. 0.79. What is the ratio of the Imports (BoP, current US$) of Kazakhstan in 2009 to that in 2011?
Your answer should be compact. 0.76. What is the ratio of the Imports (BoP, current US$) of Malaysia in 2009 to that in 2011?
Provide a short and direct response. 0.67. What is the ratio of the Imports (BoP, current US$) of High income: nonOECD in 2010 to that in 2011?
Your answer should be very brief. 0.84. What is the ratio of the Imports (BoP, current US$) of France in 2010 to that in 2011?
Your response must be concise. 0.86. What is the ratio of the Imports (BoP, current US$) of Kazakhstan in 2010 to that in 2011?
Make the answer very short. 0.86. What is the ratio of the Imports (BoP, current US$) of Malaysia in 2010 to that in 2011?
Provide a short and direct response. 0.87. What is the difference between the highest and the second highest Imports (BoP, current US$) in High income: nonOECD?
Your answer should be very brief. 3.88e+11. What is the difference between the highest and the second highest Imports (BoP, current US$) of France?
Your answer should be very brief. 1.06e+1. What is the difference between the highest and the second highest Imports (BoP, current US$) of Kazakhstan?
Offer a very short reply. 1.75e+09. What is the difference between the highest and the second highest Imports (BoP, current US$) of Malaysia?
Offer a terse response. 2.78e+1. What is the difference between the highest and the lowest Imports (BoP, current US$) of High income: nonOECD?
Keep it short and to the point. 1.04e+12. What is the difference between the highest and the lowest Imports (BoP, current US$) in France?
Ensure brevity in your answer.  2.21e+11. What is the difference between the highest and the lowest Imports (BoP, current US$) of Kazakhstan?
Make the answer very short. 1.84e+1. What is the difference between the highest and the lowest Imports (BoP, current US$) of Malaysia?
Keep it short and to the point. 7.25e+1. 